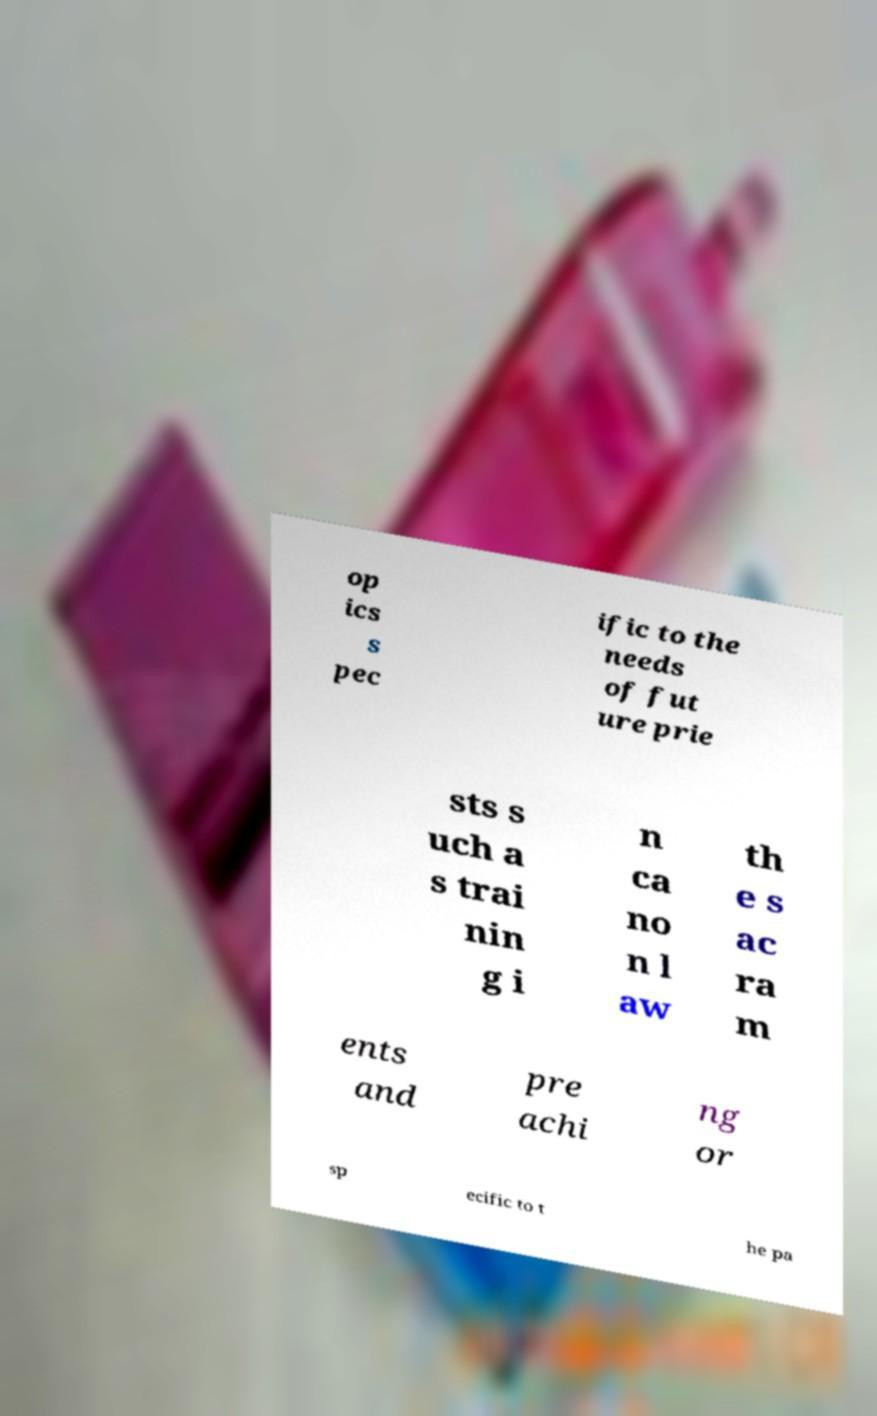Please read and relay the text visible in this image. What does it say? op ics s pec ific to the needs of fut ure prie sts s uch a s trai nin g i n ca no n l aw th e s ac ra m ents and pre achi ng or sp ecific to t he pa 